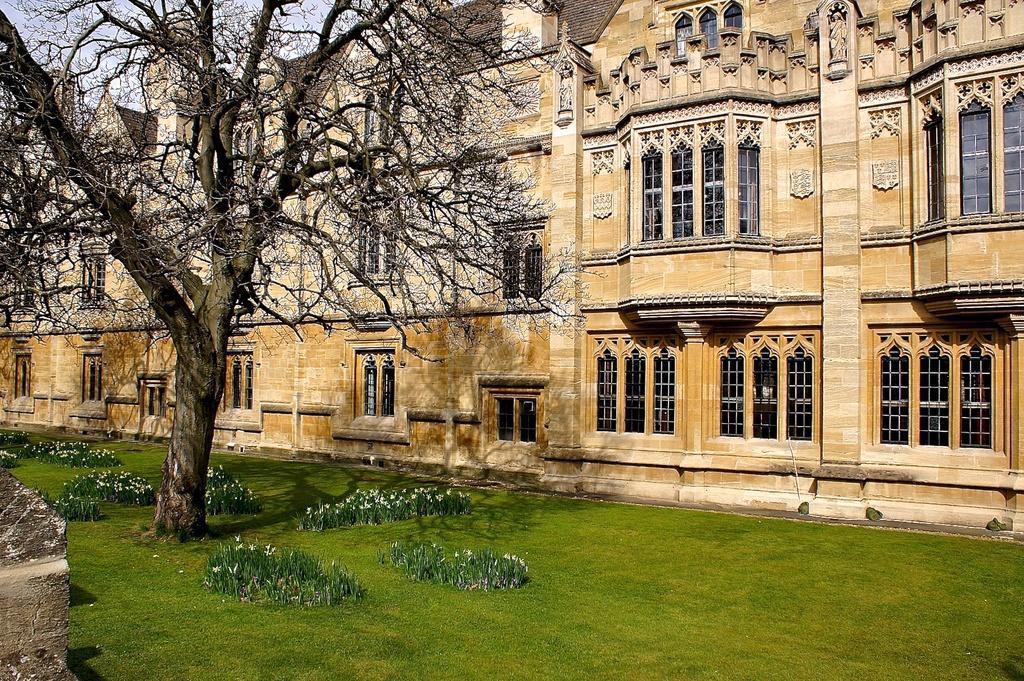Can you describe this image briefly? In this picture we can see a building here, there are some glass windows here, at the bottom there is grass, we can see some plants and a tree here, there is the sky at the left top of the picture. 